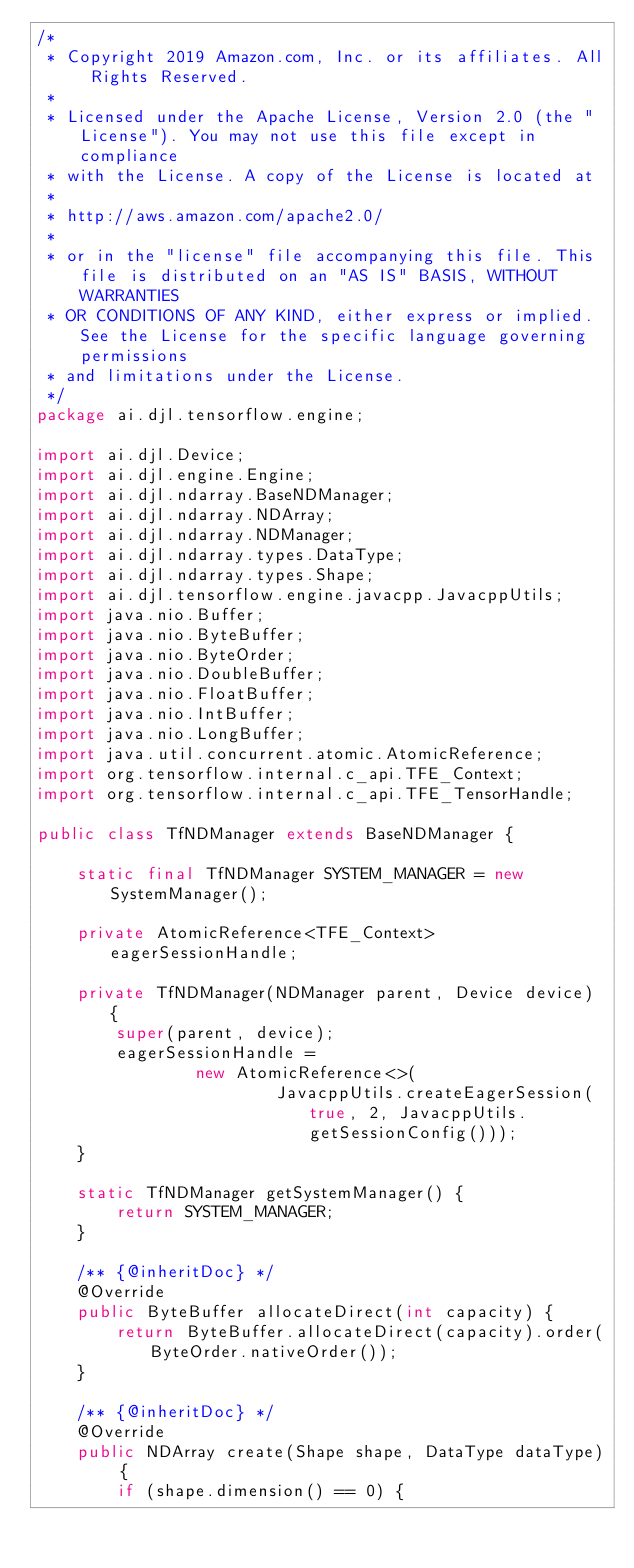Convert code to text. <code><loc_0><loc_0><loc_500><loc_500><_Java_>/*
 * Copyright 2019 Amazon.com, Inc. or its affiliates. All Rights Reserved.
 *
 * Licensed under the Apache License, Version 2.0 (the "License"). You may not use this file except in compliance
 * with the License. A copy of the License is located at
 *
 * http://aws.amazon.com/apache2.0/
 *
 * or in the "license" file accompanying this file. This file is distributed on an "AS IS" BASIS, WITHOUT WARRANTIES
 * OR CONDITIONS OF ANY KIND, either express or implied. See the License for the specific language governing permissions
 * and limitations under the License.
 */
package ai.djl.tensorflow.engine;

import ai.djl.Device;
import ai.djl.engine.Engine;
import ai.djl.ndarray.BaseNDManager;
import ai.djl.ndarray.NDArray;
import ai.djl.ndarray.NDManager;
import ai.djl.ndarray.types.DataType;
import ai.djl.ndarray.types.Shape;
import ai.djl.tensorflow.engine.javacpp.JavacppUtils;
import java.nio.Buffer;
import java.nio.ByteBuffer;
import java.nio.ByteOrder;
import java.nio.DoubleBuffer;
import java.nio.FloatBuffer;
import java.nio.IntBuffer;
import java.nio.LongBuffer;
import java.util.concurrent.atomic.AtomicReference;
import org.tensorflow.internal.c_api.TFE_Context;
import org.tensorflow.internal.c_api.TFE_TensorHandle;

public class TfNDManager extends BaseNDManager {

    static final TfNDManager SYSTEM_MANAGER = new SystemManager();

    private AtomicReference<TFE_Context> eagerSessionHandle;

    private TfNDManager(NDManager parent, Device device) {
        super(parent, device);
        eagerSessionHandle =
                new AtomicReference<>(
                        JavacppUtils.createEagerSession(true, 2, JavacppUtils.getSessionConfig()));
    }

    static TfNDManager getSystemManager() {
        return SYSTEM_MANAGER;
    }

    /** {@inheritDoc} */
    @Override
    public ByteBuffer allocateDirect(int capacity) {
        return ByteBuffer.allocateDirect(capacity).order(ByteOrder.nativeOrder());
    }

    /** {@inheritDoc} */
    @Override
    public NDArray create(Shape shape, DataType dataType) {
        if (shape.dimension() == 0) {</code> 